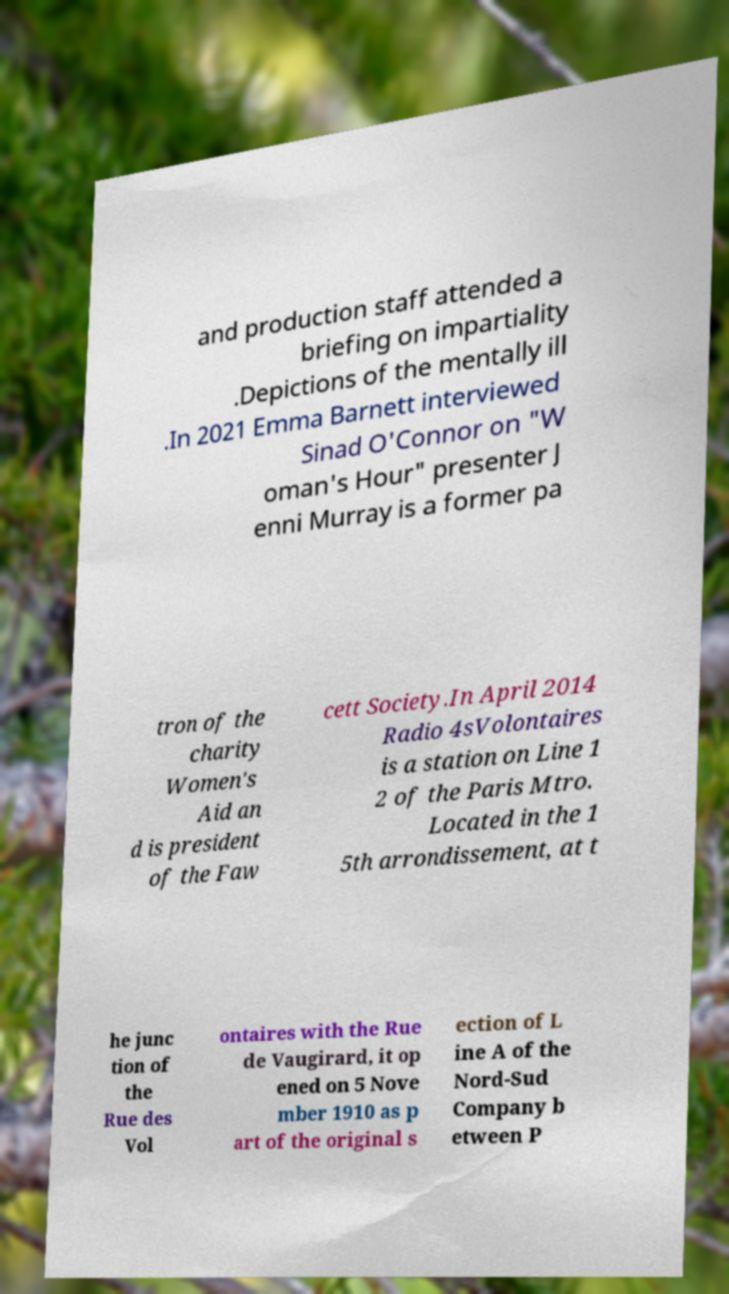Can you read and provide the text displayed in the image?This photo seems to have some interesting text. Can you extract and type it out for me? and production staff attended a briefing on impartiality .Depictions of the mentally ill .In 2021 Emma Barnett interviewed Sinad O'Connor on "W oman's Hour" presenter J enni Murray is a former pa tron of the charity Women's Aid an d is president of the Faw cett Society.In April 2014 Radio 4sVolontaires is a station on Line 1 2 of the Paris Mtro. Located in the 1 5th arrondissement, at t he junc tion of the Rue des Vol ontaires with the Rue de Vaugirard, it op ened on 5 Nove mber 1910 as p art of the original s ection of L ine A of the Nord-Sud Company b etween P 